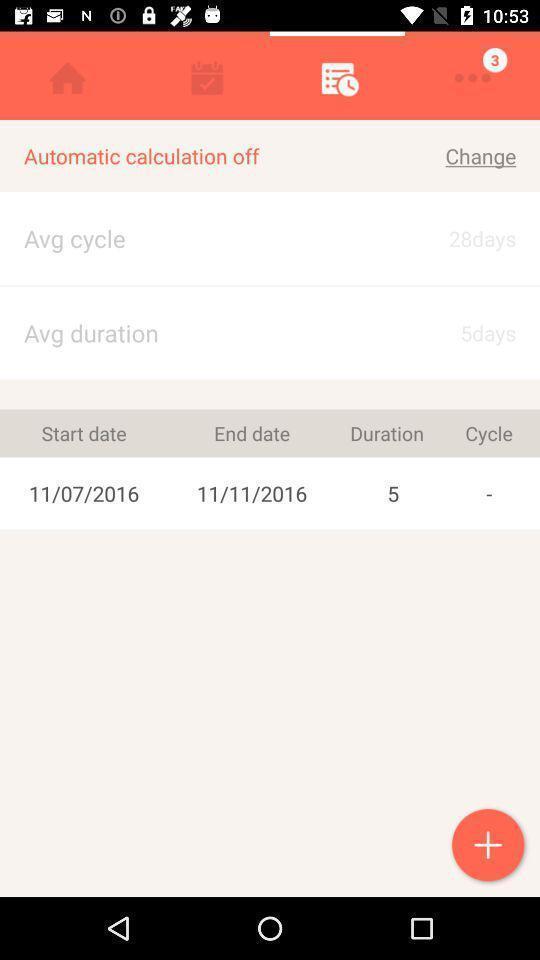Give me a narrative description of this picture. Page for calculating menstrual cycle of a period tracking app. 